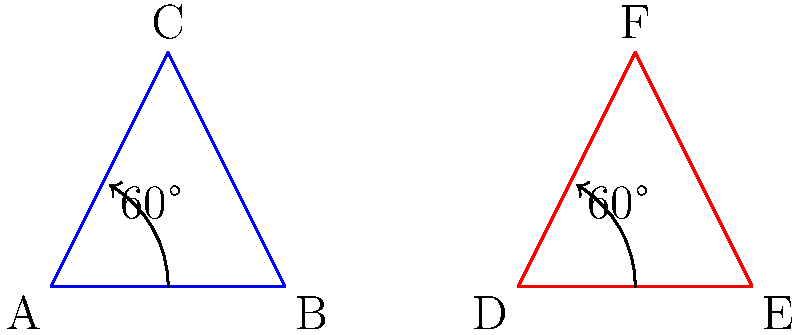In this stylized representation of Ja Morant's signature spin move, triangle ABC represents his starting position, and triangle DEF represents his position after the spin. If these triangles are congruent and the rotation angle is 60°, what is the measure of angle BAC? Let's approach this step-by-step:

1) First, we know that triangles ABC and DEF are congruent. This means all their corresponding angles are equal.

2) The rotation angle given is 60°. This tells us that the entire triangle has been rotated by 60°.

3) In an equilateral triangle, all angles are equal and measure 60°. If the rotation matches one of the angles of the triangle, it suggests that the triangle might be equilateral.

4) To confirm this, let's consider the properties of the rotation:
   - It preserves the shape and size of the triangle (congruence).
   - It rotates the triangle exactly onto itself.

5) The only triangle that can be rotated 60° and match exactly with its original position is an equilateral triangle.

6) In an equilateral triangle, all angles are equal and measure 60°.

Therefore, angle BAC, being one of the angles of this equilateral triangle, must measure 60°.
Answer: 60° 